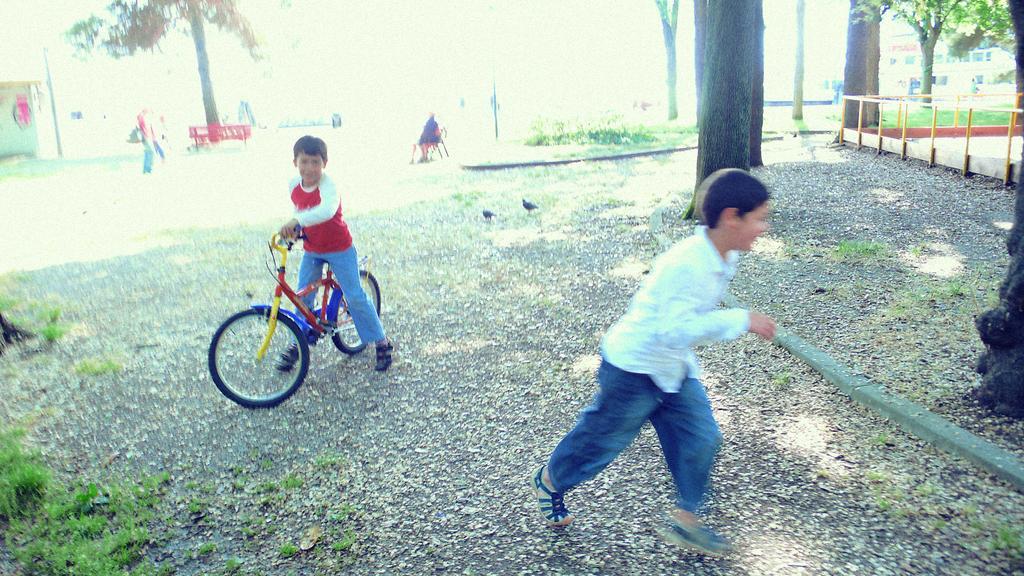Can you describe this image briefly? In this image there are two persons, one child is riding a bicycle, he is wearing a red t shirt, blue jeans and black sandals. The person towards the right he is wearing white shirt, blue jeans and blue shoes. In the background there are some people, trees and grass. 